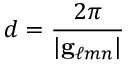Convert formula to latex. <formula><loc_0><loc_0><loc_500><loc_500>d = { \frac { 2 \pi } { | g _ { \ell m n } | } }</formula> 